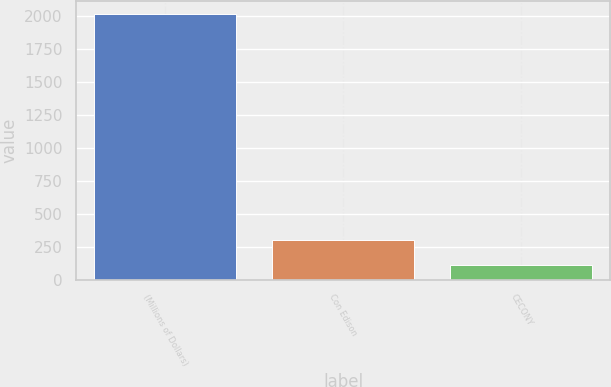<chart> <loc_0><loc_0><loc_500><loc_500><bar_chart><fcel>(Millions of Dollars)<fcel>Con Edison<fcel>CECONY<nl><fcel>2013<fcel>302.1<fcel>112<nl></chart> 